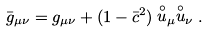<formula> <loc_0><loc_0><loc_500><loc_500>\bar { g } _ { \mu \nu } = g _ { \mu \nu } + ( 1 - \bar { c } ^ { 2 } ) \stackrel { \circ } u _ { \mu } \stackrel { \circ } u _ { \nu } .</formula> 